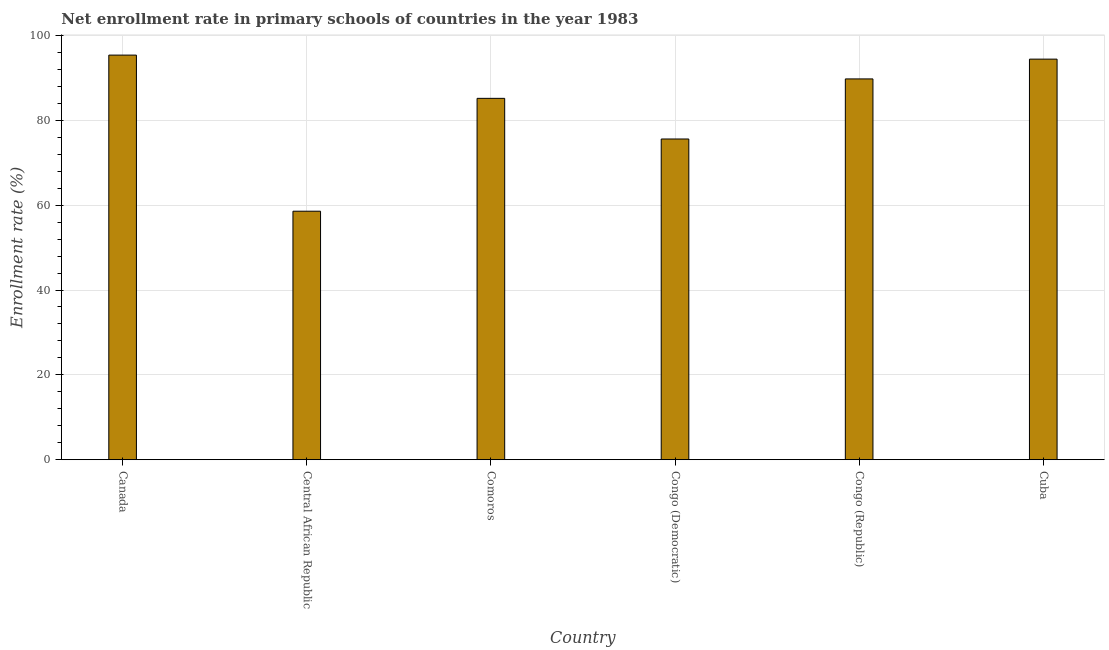Does the graph contain any zero values?
Your response must be concise. No. What is the title of the graph?
Ensure brevity in your answer.  Net enrollment rate in primary schools of countries in the year 1983. What is the label or title of the X-axis?
Make the answer very short. Country. What is the label or title of the Y-axis?
Keep it short and to the point. Enrollment rate (%). What is the net enrollment rate in primary schools in Congo (Republic)?
Make the answer very short. 89.76. Across all countries, what is the maximum net enrollment rate in primary schools?
Provide a succinct answer. 95.37. Across all countries, what is the minimum net enrollment rate in primary schools?
Ensure brevity in your answer.  58.57. In which country was the net enrollment rate in primary schools maximum?
Provide a short and direct response. Canada. In which country was the net enrollment rate in primary schools minimum?
Give a very brief answer. Central African Republic. What is the sum of the net enrollment rate in primary schools?
Ensure brevity in your answer.  498.91. What is the difference between the net enrollment rate in primary schools in Central African Republic and Cuba?
Ensure brevity in your answer.  -35.85. What is the average net enrollment rate in primary schools per country?
Give a very brief answer. 83.15. What is the median net enrollment rate in primary schools?
Ensure brevity in your answer.  87.47. In how many countries, is the net enrollment rate in primary schools greater than 64 %?
Offer a terse response. 5. What is the ratio of the net enrollment rate in primary schools in Canada to that in Central African Republic?
Give a very brief answer. 1.63. Is the difference between the net enrollment rate in primary schools in Canada and Central African Republic greater than the difference between any two countries?
Provide a short and direct response. Yes. What is the difference between the highest and the second highest net enrollment rate in primary schools?
Your response must be concise. 0.95. What is the difference between the highest and the lowest net enrollment rate in primary schools?
Give a very brief answer. 36.8. How many bars are there?
Provide a succinct answer. 6. Are all the bars in the graph horizontal?
Keep it short and to the point. No. How many countries are there in the graph?
Give a very brief answer. 6. What is the difference between two consecutive major ticks on the Y-axis?
Your answer should be compact. 20. Are the values on the major ticks of Y-axis written in scientific E-notation?
Give a very brief answer. No. What is the Enrollment rate (%) of Canada?
Keep it short and to the point. 95.37. What is the Enrollment rate (%) of Central African Republic?
Offer a terse response. 58.57. What is the Enrollment rate (%) of Comoros?
Provide a succinct answer. 85.18. What is the Enrollment rate (%) in Congo (Democratic)?
Give a very brief answer. 75.6. What is the Enrollment rate (%) of Congo (Republic)?
Your answer should be compact. 89.76. What is the Enrollment rate (%) of Cuba?
Make the answer very short. 94.42. What is the difference between the Enrollment rate (%) in Canada and Central African Republic?
Make the answer very short. 36.8. What is the difference between the Enrollment rate (%) in Canada and Comoros?
Offer a very short reply. 10.2. What is the difference between the Enrollment rate (%) in Canada and Congo (Democratic)?
Give a very brief answer. 19.78. What is the difference between the Enrollment rate (%) in Canada and Congo (Republic)?
Provide a short and direct response. 5.61. What is the difference between the Enrollment rate (%) in Canada and Cuba?
Make the answer very short. 0.95. What is the difference between the Enrollment rate (%) in Central African Republic and Comoros?
Provide a succinct answer. -26.6. What is the difference between the Enrollment rate (%) in Central African Republic and Congo (Democratic)?
Provide a succinct answer. -17.02. What is the difference between the Enrollment rate (%) in Central African Republic and Congo (Republic)?
Your response must be concise. -31.19. What is the difference between the Enrollment rate (%) in Central African Republic and Cuba?
Keep it short and to the point. -35.85. What is the difference between the Enrollment rate (%) in Comoros and Congo (Democratic)?
Provide a short and direct response. 9.58. What is the difference between the Enrollment rate (%) in Comoros and Congo (Republic)?
Provide a succinct answer. -4.58. What is the difference between the Enrollment rate (%) in Comoros and Cuba?
Offer a very short reply. -9.25. What is the difference between the Enrollment rate (%) in Congo (Democratic) and Congo (Republic)?
Provide a short and direct response. -14.16. What is the difference between the Enrollment rate (%) in Congo (Democratic) and Cuba?
Keep it short and to the point. -18.83. What is the difference between the Enrollment rate (%) in Congo (Republic) and Cuba?
Your answer should be compact. -4.66. What is the ratio of the Enrollment rate (%) in Canada to that in Central African Republic?
Your answer should be very brief. 1.63. What is the ratio of the Enrollment rate (%) in Canada to that in Comoros?
Give a very brief answer. 1.12. What is the ratio of the Enrollment rate (%) in Canada to that in Congo (Democratic)?
Offer a very short reply. 1.26. What is the ratio of the Enrollment rate (%) in Canada to that in Congo (Republic)?
Ensure brevity in your answer.  1.06. What is the ratio of the Enrollment rate (%) in Canada to that in Cuba?
Offer a terse response. 1.01. What is the ratio of the Enrollment rate (%) in Central African Republic to that in Comoros?
Give a very brief answer. 0.69. What is the ratio of the Enrollment rate (%) in Central African Republic to that in Congo (Democratic)?
Your answer should be very brief. 0.78. What is the ratio of the Enrollment rate (%) in Central African Republic to that in Congo (Republic)?
Provide a succinct answer. 0.65. What is the ratio of the Enrollment rate (%) in Central African Republic to that in Cuba?
Offer a very short reply. 0.62. What is the ratio of the Enrollment rate (%) in Comoros to that in Congo (Democratic)?
Offer a very short reply. 1.13. What is the ratio of the Enrollment rate (%) in Comoros to that in Congo (Republic)?
Provide a short and direct response. 0.95. What is the ratio of the Enrollment rate (%) in Comoros to that in Cuba?
Offer a very short reply. 0.9. What is the ratio of the Enrollment rate (%) in Congo (Democratic) to that in Congo (Republic)?
Your answer should be compact. 0.84. What is the ratio of the Enrollment rate (%) in Congo (Democratic) to that in Cuba?
Keep it short and to the point. 0.8. What is the ratio of the Enrollment rate (%) in Congo (Republic) to that in Cuba?
Keep it short and to the point. 0.95. 